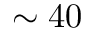Convert formula to latex. <formula><loc_0><loc_0><loc_500><loc_500>\sim 4 0</formula> 